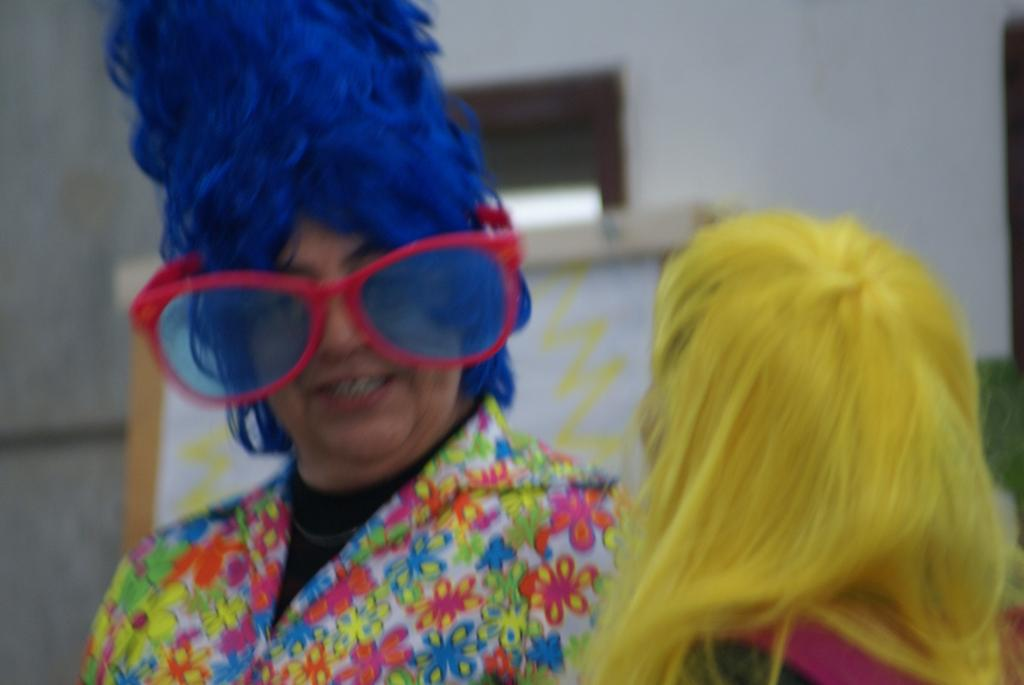How many people are in the foreground of the image? There are two persons in the foreground of the image. What are the persons wearing? The persons are wearing costumes. What can be seen in the background of the image? There is a board and a window in the background of the image. What type of bells can be heard ringing in the image? There are no bells present in the image, and therefore no sound can be heard. 